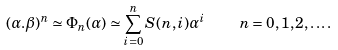Convert formula to latex. <formula><loc_0><loc_0><loc_500><loc_500>( \alpha . \beta ) ^ { n } \simeq \Phi _ { n } ( \alpha ) \simeq \sum _ { i = 0 } ^ { n } S ( n , i ) \alpha ^ { i } \quad n = 0 , 1 , 2 , \dots .</formula> 